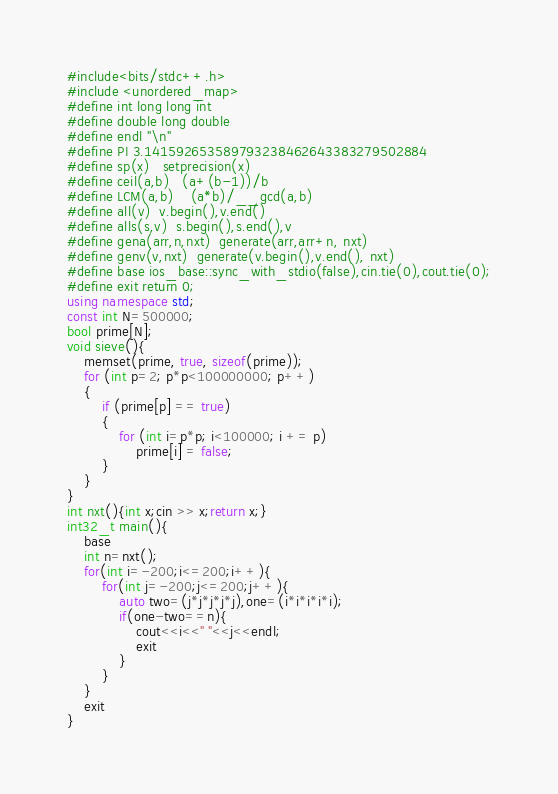Convert code to text. <code><loc_0><loc_0><loc_500><loc_500><_C++_>#include<bits/stdc++.h>
#include <unordered_map>
#define int long long int
#define double long double
#define endl "\n"
#define PI 3.141592653589793238462643383279502884
#define sp(x)   setprecision(x)
#define ceil(a,b)   (a+(b-1))/b
#define LCM(a,b)    (a*b)/__gcd(a,b)
#define all(v)  v.begin(),v.end()
#define alls(s,v)  s.begin(),s.end(),v
#define gena(arr,n,nxt)  generate(arr,arr+n, nxt)
#define genv(v,nxt)  generate(v.begin(),v.end(), nxt)
#define base ios_base::sync_with_stdio(false),cin.tie(0),cout.tie(0);
#define exit return 0;
using namespace std;
const int N=500000;
bool prime[N];
void sieve(){
    memset(prime, true, sizeof(prime));
    for (int p=2; p*p<100000000; p++)
    {
        if (prime[p] == true)
        {
            for (int i=p*p; i<100000; i += p)
                prime[i] = false;
        }
    }
}
int nxt(){int x;cin >> x;return x;}
int32_t main(){
    base
    int n=nxt();
    for(int i=-200;i<=200;i++){
        for(int j=-200;j<=200;j++){
            auto two=(j*j*j*j*j),one=(i*i*i*i*i);
            if(one-two==n){
                cout<<i<<" "<<j<<endl;
                exit
            }
        }
    }
    exit
}
</code> 